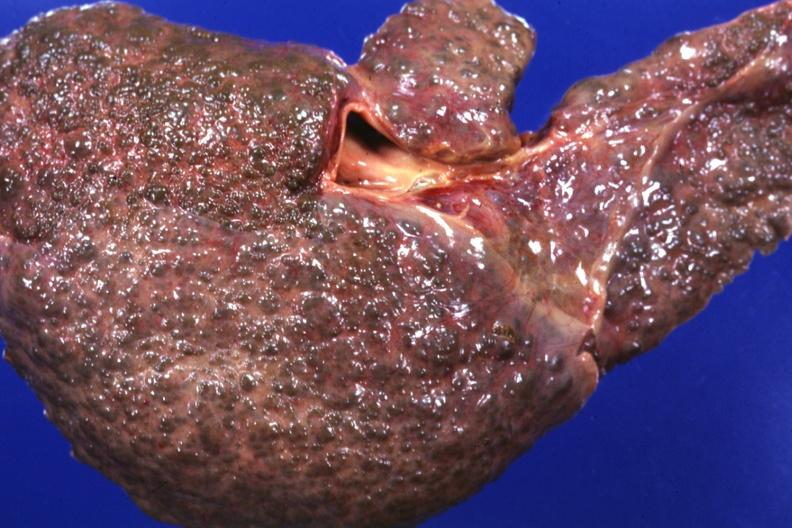s fracture present?
Answer the question using a single word or phrase. No 